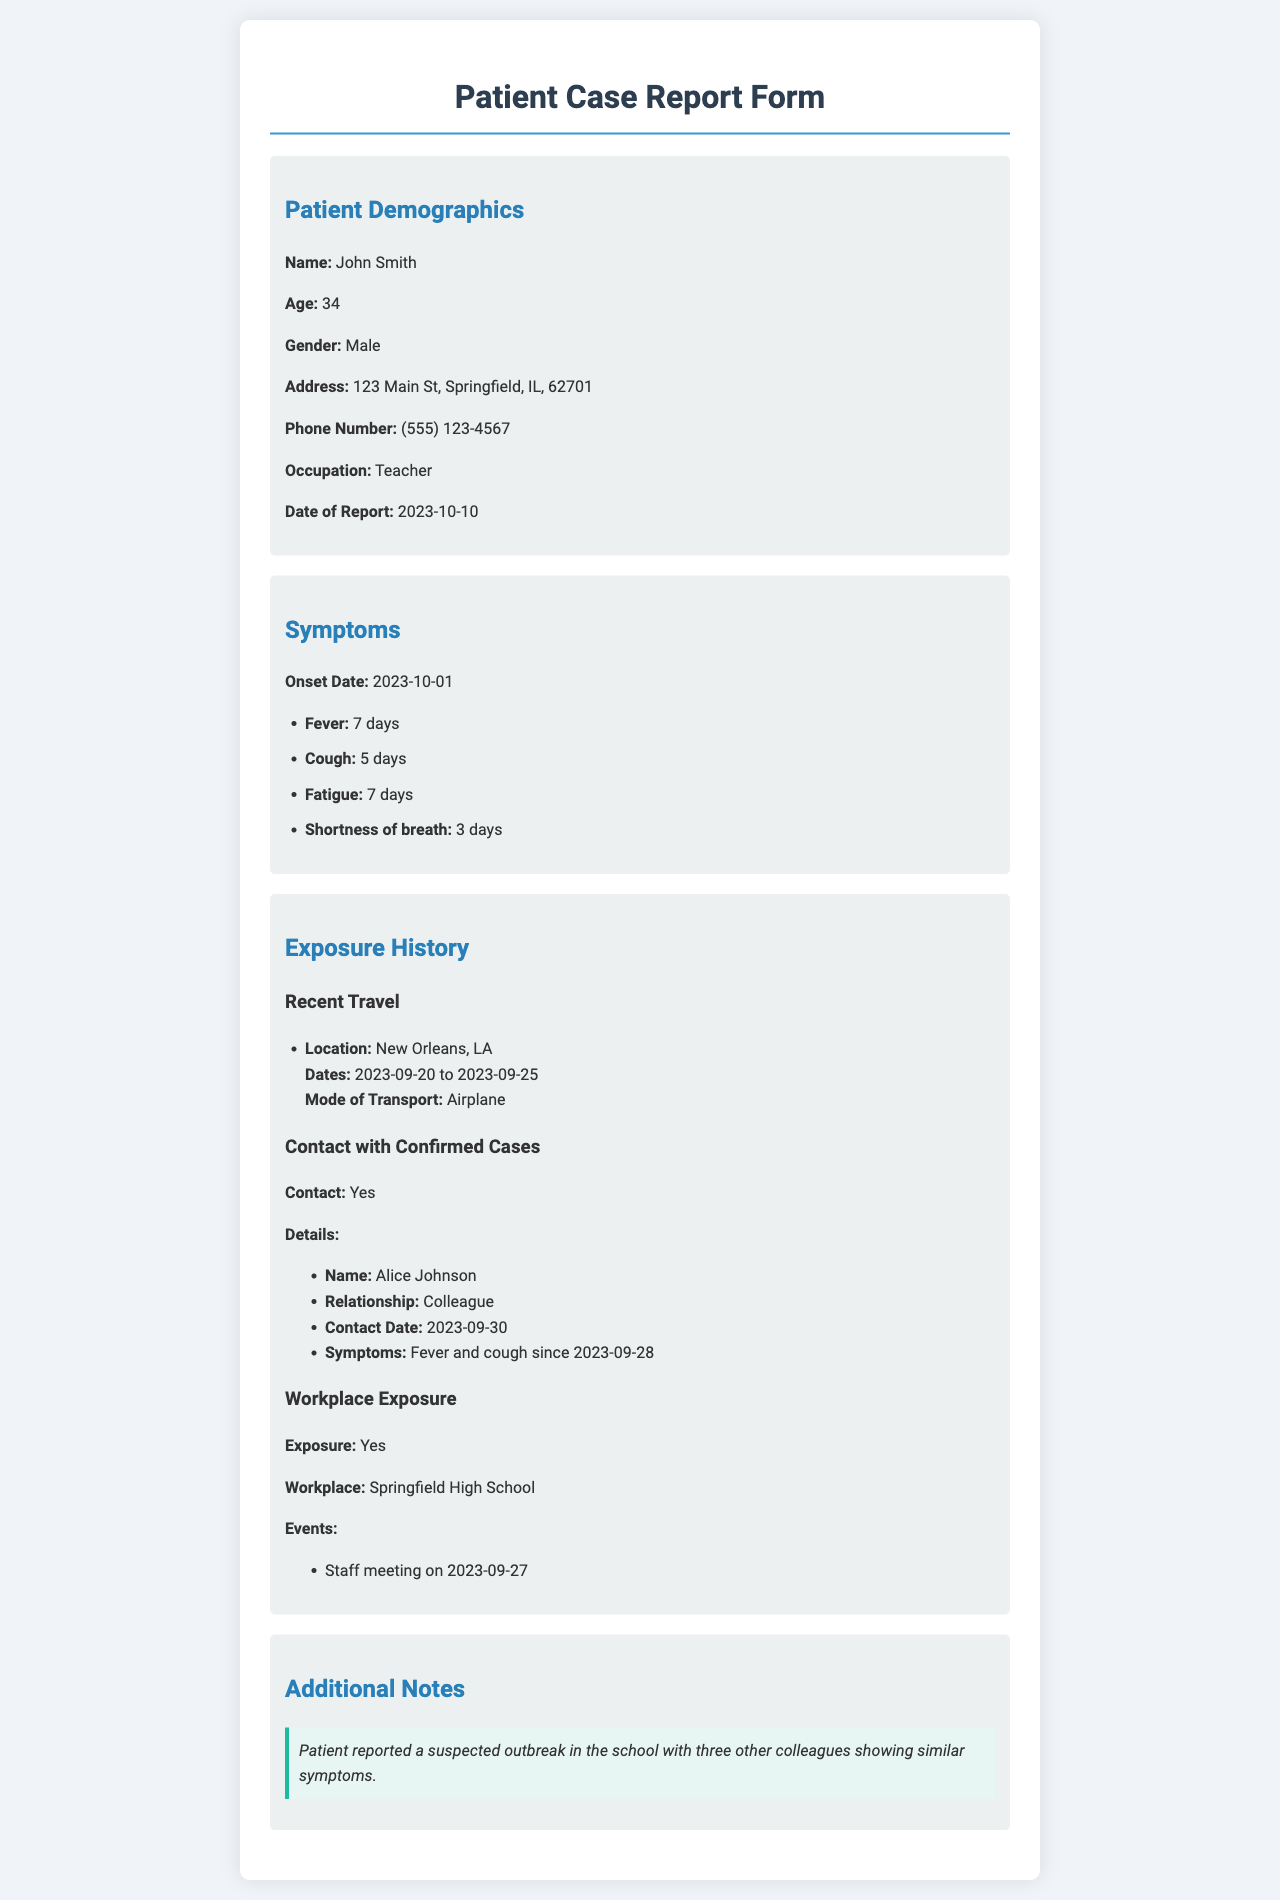What is the patient's name? The patient's name is mentioned in the demographic section of the document.
Answer: John Smith What is the patient's age? The document provides the patient's age in the demographics section.
Answer: 34 What symptoms did the patient report? The symptoms are listed under the symptoms section, revealing the patient's condition.
Answer: Fever, Cough, Fatigue, Shortness of breath When did the symptoms start? The onset date of symptoms is explicitly stated in the document.
Answer: 2023-10-01 How many days has the patient had a cough? The duration of the cough is specified in the symptoms section.
Answer: 5 days Where did the patient travel recently? The location of recent travel is highlighted under the exposure history section.
Answer: New Orleans, LA How many confirmed cases did the patient have contact with? The exposure history states contact with confirmed cases, making this information clear.
Answer: 1 What workplace event did the patient attend that could be connected to exposure? The workplace exposure section details specific events related to potential exposure.
Answer: Staff meeting on 2023-09-27 What additional information does the patient provide about the outbreak? The additional notes section contains information regarding the suspected outbreak.
Answer: Three other colleagues showing similar symptoms 